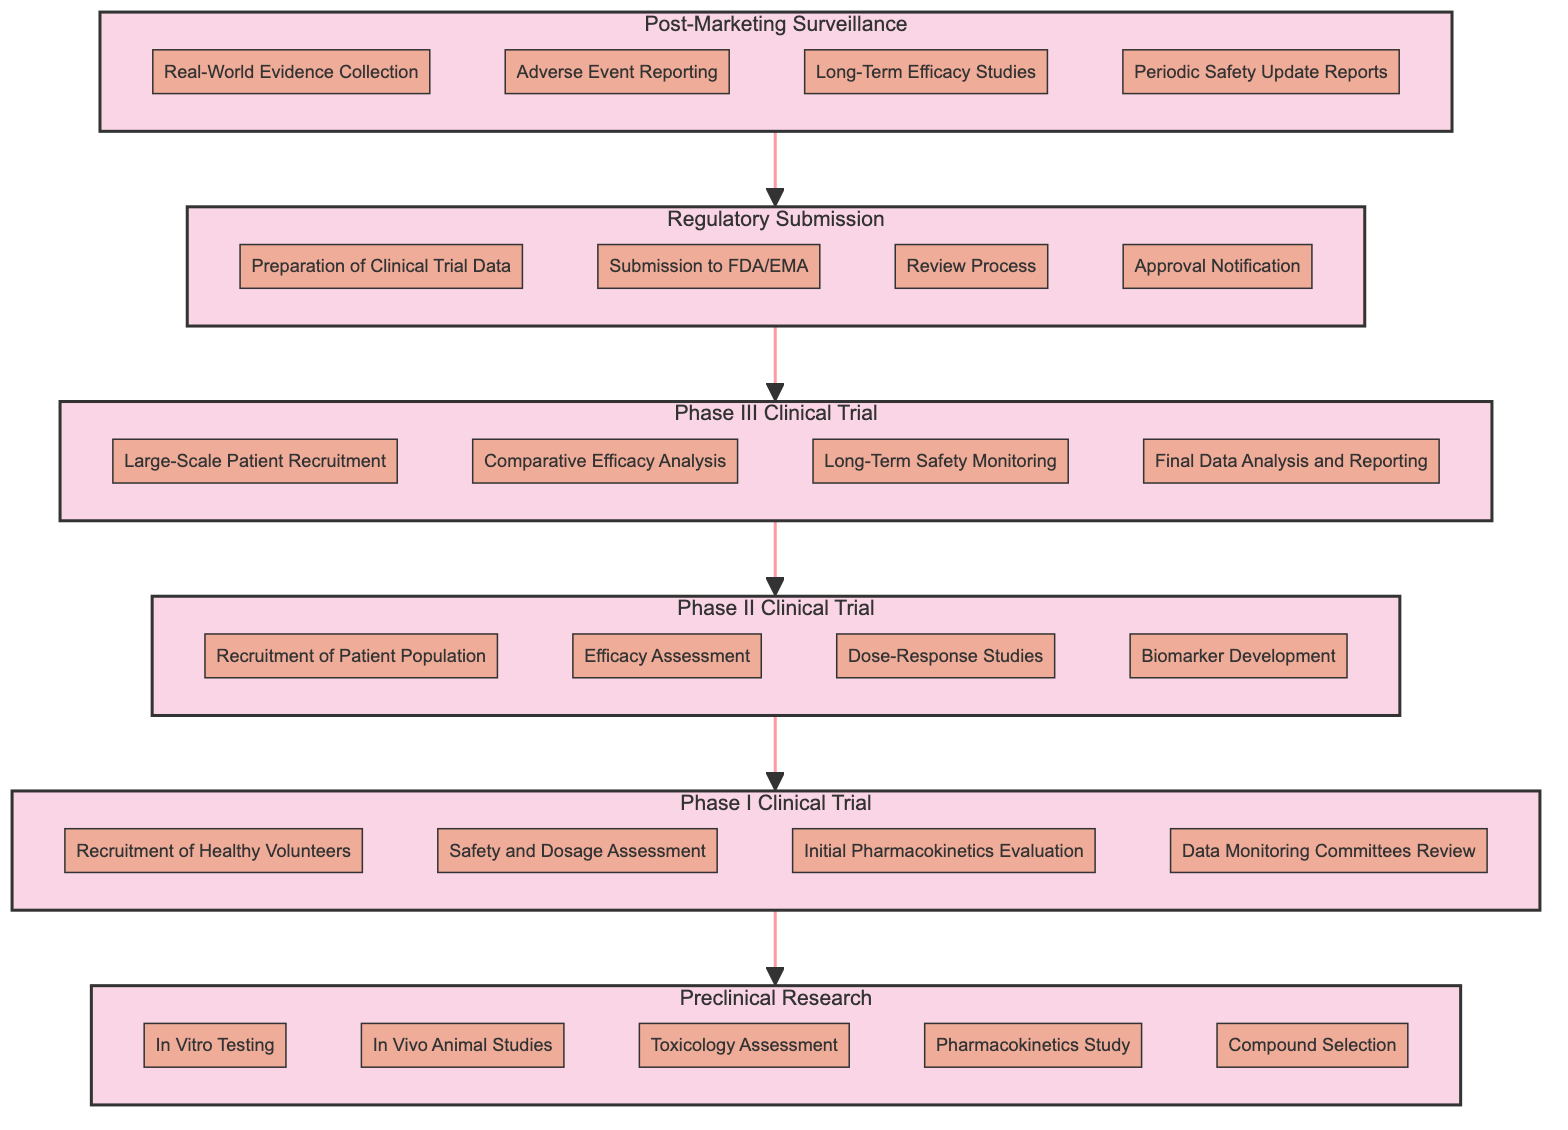What is the first milestone in the Preclinical Research phase? In the bottom-up flow chart, the Preclinical Research phase is the lowest phase, and the milestones within it are listed directly underneath it. The first milestone listed is "In Vitro Testing."
Answer: In Vitro Testing How many milestones are there in Phase I Clinical Trial? The diagram shows four milestones listed under the Phase I Clinical Trial subgraph. By counting these, we see there are four milestones in total.
Answer: 4 What phase comes after Regulatory Submission? The diagram indicates that the Regulatory Submission phase is followed by the Phase III Clinical Trial phase, as represented by the directed arrow connecting these two phases.
Answer: Phase III Clinical Trial Which phase has milestones related to "Efficacy Assessment"? Upon examining the milestones, "Efficacy Assessment" is specifically listed under Phase II Clinical Trial, indicating that it's the phase that focuses on this milestone.
Answer: Phase II Clinical Trial How does the number of milestones in Phase II compare to the number in Phase I? Phase II Clinical Trial has four milestones, while Phase I Clinical Trial also has four milestones. Therefore, they are equal in the number of milestones.
Answer: Equal What is the last milestone in the Post-Marketing Surveillance phase? In the Post-Marketing Surveillance section, the last milestone is "Periodic Safety Update Reports," which can be seen as the final item in the list of milestones for this phase.
Answer: Periodic Safety Update Reports How many phases have a milestone related to patient recruitment? By inspecting the diagram, both Phase I and Phase III Clinical Trial phases contain milestones related to patient recruitment: "Recruitment of Healthy Volunteers" in Phase I, and "Large-Scale Patient Recruitment" in Phase III. Thus, there are two phases with such milestones.
Answer: 2 What milestone follows "Initial Pharmacokinetics Evaluation" in Phase I Clinical Trial? The milestones for Phase I Clinical Trial are listed sequentially. After "Initial Pharmacokinetics Evaluation," the next milestone is "Data Monitoring Committees Review."
Answer: Data Monitoring Committees Review Which phase is indicated to follow Phase III Clinical Trial in the diagram? According to the flow of the diagram, the phase that directly follows Phase III Clinical Trial is the Regulatory Submission phase, as indicated by the directed arrow leading from Phase III to Regulatory Submission.
Answer: Regulatory Submission 